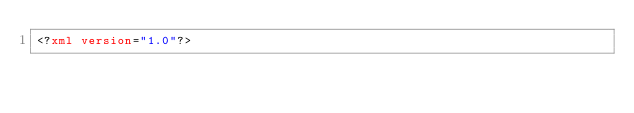Convert code to text. <code><loc_0><loc_0><loc_500><loc_500><_XML_><?xml version="1.0"?></code> 